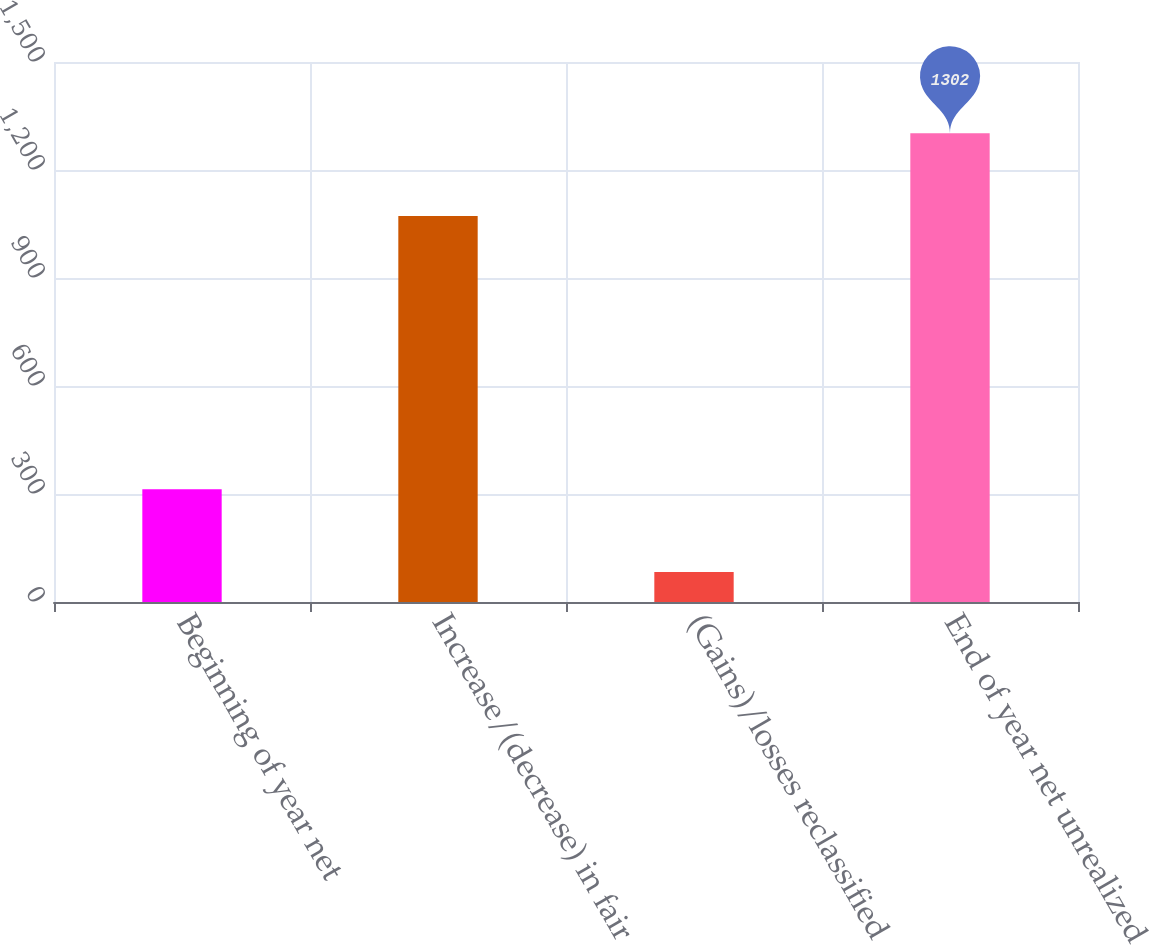<chart> <loc_0><loc_0><loc_500><loc_500><bar_chart><fcel>Beginning of year net<fcel>Increase/(decrease) in fair<fcel>(Gains)/losses reclassified<fcel>End of year net unrealized<nl><fcel>313<fcel>1072<fcel>83<fcel>1302<nl></chart> 